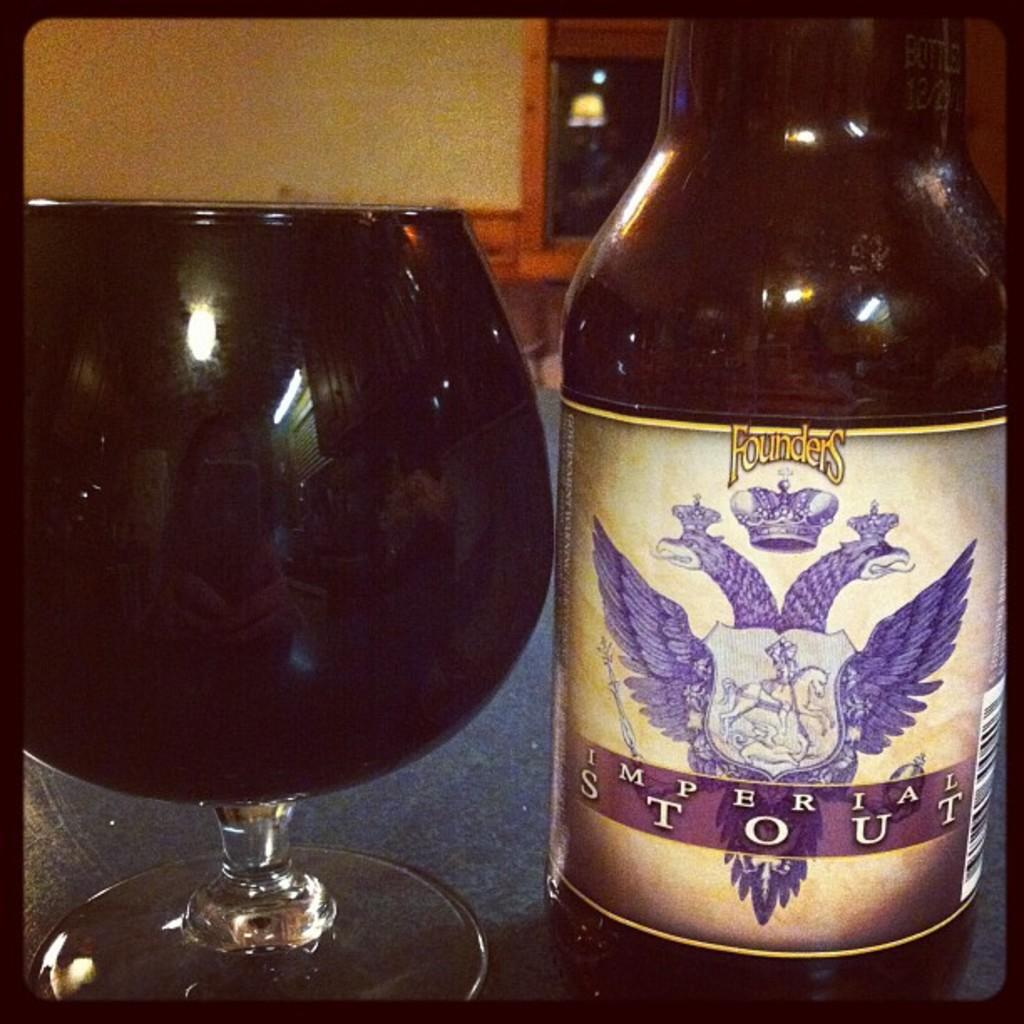Provide a one-sentence caption for the provided image. Bottle of Founders Imperial Stout beer next to a full glass of beer. 